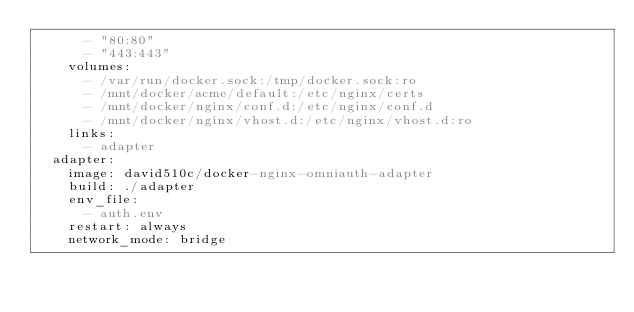<code> <loc_0><loc_0><loc_500><loc_500><_YAML_>      - "80:80"
      - "443:443"
    volumes:
      - /var/run/docker.sock:/tmp/docker.sock:ro
      - /mnt/docker/acme/default:/etc/nginx/certs
      - /mnt/docker/nginx/conf.d:/etc/nginx/conf.d
      - /mnt/docker/nginx/vhost.d:/etc/nginx/vhost.d:ro
    links:
      - adapter
  adapter:
    image: david510c/docker-nginx-omniauth-adapter
    build: ./adapter
    env_file:
      - auth.env
    restart: always
    network_mode: bridge
</code> 